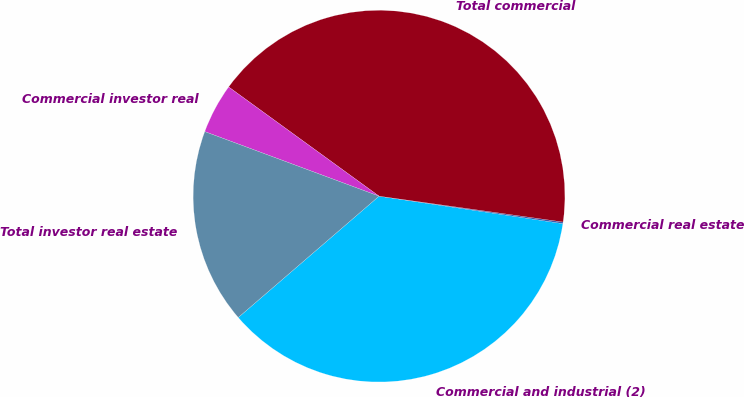Convert chart. <chart><loc_0><loc_0><loc_500><loc_500><pie_chart><fcel>Commercial and industrial (2)<fcel>Commercial real estate<fcel>Total commercial<fcel>Commercial investor real<fcel>Total investor real estate<nl><fcel>36.32%<fcel>0.14%<fcel>42.23%<fcel>4.35%<fcel>16.97%<nl></chart> 